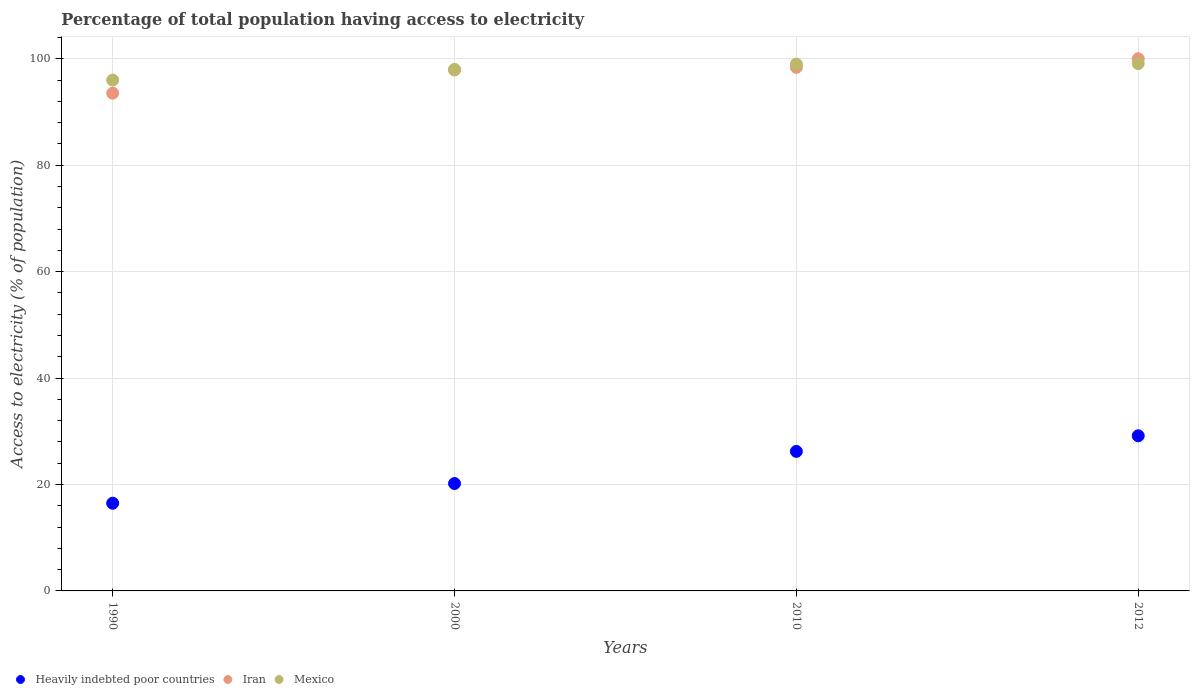Is the number of dotlines equal to the number of legend labels?
Provide a succinct answer. Yes. What is the percentage of population that have access to electricity in Iran in 2012?
Your answer should be very brief. 100. Across all years, what is the maximum percentage of population that have access to electricity in Iran?
Offer a very short reply. 100. Across all years, what is the minimum percentage of population that have access to electricity in Heavily indebted poor countries?
Offer a terse response. 16.48. What is the total percentage of population that have access to electricity in Iran in the graph?
Give a very brief answer. 389.84. What is the difference between the percentage of population that have access to electricity in Mexico in 2000 and that in 2012?
Give a very brief answer. -1.1. What is the difference between the percentage of population that have access to electricity in Mexico in 2012 and the percentage of population that have access to electricity in Heavily indebted poor countries in 2010?
Provide a succinct answer. 72.88. What is the average percentage of population that have access to electricity in Heavily indebted poor countries per year?
Your response must be concise. 23.01. In the year 2012, what is the difference between the percentage of population that have access to electricity in Heavily indebted poor countries and percentage of population that have access to electricity in Mexico?
Provide a succinct answer. -69.95. What is the ratio of the percentage of population that have access to electricity in Heavily indebted poor countries in 1990 to that in 2000?
Ensure brevity in your answer.  0.82. Is the percentage of population that have access to electricity in Iran in 2000 less than that in 2010?
Your answer should be very brief. Yes. What is the difference between the highest and the second highest percentage of population that have access to electricity in Mexico?
Your answer should be compact. 0.1. What is the difference between the highest and the lowest percentage of population that have access to electricity in Iran?
Your response must be concise. 6.46. In how many years, is the percentage of population that have access to electricity in Heavily indebted poor countries greater than the average percentage of population that have access to electricity in Heavily indebted poor countries taken over all years?
Your answer should be very brief. 2. Is the sum of the percentage of population that have access to electricity in Mexico in 1990 and 2010 greater than the maximum percentage of population that have access to electricity in Heavily indebted poor countries across all years?
Keep it short and to the point. Yes. Is the percentage of population that have access to electricity in Iran strictly less than the percentage of population that have access to electricity in Heavily indebted poor countries over the years?
Ensure brevity in your answer.  No. How many dotlines are there?
Provide a succinct answer. 3. What is the difference between two consecutive major ticks on the Y-axis?
Provide a short and direct response. 20. How many legend labels are there?
Make the answer very short. 3. What is the title of the graph?
Provide a short and direct response. Percentage of total population having access to electricity. What is the label or title of the X-axis?
Give a very brief answer. Years. What is the label or title of the Y-axis?
Make the answer very short. Access to electricity (% of population). What is the Access to electricity (% of population) of Heavily indebted poor countries in 1990?
Offer a terse response. 16.48. What is the Access to electricity (% of population) in Iran in 1990?
Provide a short and direct response. 93.54. What is the Access to electricity (% of population) of Mexico in 1990?
Your answer should be very brief. 96. What is the Access to electricity (% of population) of Heavily indebted poor countries in 2000?
Make the answer very short. 20.18. What is the Access to electricity (% of population) of Iran in 2000?
Offer a terse response. 97.9. What is the Access to electricity (% of population) of Heavily indebted poor countries in 2010?
Offer a terse response. 26.22. What is the Access to electricity (% of population) in Iran in 2010?
Ensure brevity in your answer.  98.4. What is the Access to electricity (% of population) in Mexico in 2010?
Ensure brevity in your answer.  99. What is the Access to electricity (% of population) in Heavily indebted poor countries in 2012?
Make the answer very short. 29.15. What is the Access to electricity (% of population) in Mexico in 2012?
Your answer should be very brief. 99.1. Across all years, what is the maximum Access to electricity (% of population) of Heavily indebted poor countries?
Offer a terse response. 29.15. Across all years, what is the maximum Access to electricity (% of population) in Iran?
Give a very brief answer. 100. Across all years, what is the maximum Access to electricity (% of population) in Mexico?
Provide a short and direct response. 99.1. Across all years, what is the minimum Access to electricity (% of population) of Heavily indebted poor countries?
Your answer should be very brief. 16.48. Across all years, what is the minimum Access to electricity (% of population) of Iran?
Offer a terse response. 93.54. Across all years, what is the minimum Access to electricity (% of population) in Mexico?
Make the answer very short. 96. What is the total Access to electricity (% of population) of Heavily indebted poor countries in the graph?
Provide a short and direct response. 92.04. What is the total Access to electricity (% of population) in Iran in the graph?
Your answer should be compact. 389.84. What is the total Access to electricity (% of population) in Mexico in the graph?
Keep it short and to the point. 392.1. What is the difference between the Access to electricity (% of population) of Heavily indebted poor countries in 1990 and that in 2000?
Ensure brevity in your answer.  -3.7. What is the difference between the Access to electricity (% of population) in Iran in 1990 and that in 2000?
Provide a short and direct response. -4.36. What is the difference between the Access to electricity (% of population) in Heavily indebted poor countries in 1990 and that in 2010?
Offer a terse response. -9.74. What is the difference between the Access to electricity (% of population) in Iran in 1990 and that in 2010?
Provide a short and direct response. -4.86. What is the difference between the Access to electricity (% of population) of Mexico in 1990 and that in 2010?
Ensure brevity in your answer.  -3. What is the difference between the Access to electricity (% of population) of Heavily indebted poor countries in 1990 and that in 2012?
Ensure brevity in your answer.  -12.67. What is the difference between the Access to electricity (% of population) in Iran in 1990 and that in 2012?
Keep it short and to the point. -6.46. What is the difference between the Access to electricity (% of population) of Heavily indebted poor countries in 2000 and that in 2010?
Provide a succinct answer. -6.04. What is the difference between the Access to electricity (% of population) of Iran in 2000 and that in 2010?
Offer a very short reply. -0.5. What is the difference between the Access to electricity (% of population) of Mexico in 2000 and that in 2010?
Provide a short and direct response. -1. What is the difference between the Access to electricity (% of population) of Heavily indebted poor countries in 2000 and that in 2012?
Your answer should be very brief. -8.97. What is the difference between the Access to electricity (% of population) in Heavily indebted poor countries in 2010 and that in 2012?
Give a very brief answer. -2.93. What is the difference between the Access to electricity (% of population) in Mexico in 2010 and that in 2012?
Your answer should be very brief. -0.1. What is the difference between the Access to electricity (% of population) in Heavily indebted poor countries in 1990 and the Access to electricity (% of population) in Iran in 2000?
Give a very brief answer. -81.42. What is the difference between the Access to electricity (% of population) of Heavily indebted poor countries in 1990 and the Access to electricity (% of population) of Mexico in 2000?
Your answer should be very brief. -81.52. What is the difference between the Access to electricity (% of population) of Iran in 1990 and the Access to electricity (% of population) of Mexico in 2000?
Provide a short and direct response. -4.46. What is the difference between the Access to electricity (% of population) in Heavily indebted poor countries in 1990 and the Access to electricity (% of population) in Iran in 2010?
Offer a terse response. -81.92. What is the difference between the Access to electricity (% of population) of Heavily indebted poor countries in 1990 and the Access to electricity (% of population) of Mexico in 2010?
Offer a very short reply. -82.52. What is the difference between the Access to electricity (% of population) of Iran in 1990 and the Access to electricity (% of population) of Mexico in 2010?
Ensure brevity in your answer.  -5.46. What is the difference between the Access to electricity (% of population) of Heavily indebted poor countries in 1990 and the Access to electricity (% of population) of Iran in 2012?
Your answer should be compact. -83.52. What is the difference between the Access to electricity (% of population) of Heavily indebted poor countries in 1990 and the Access to electricity (% of population) of Mexico in 2012?
Give a very brief answer. -82.62. What is the difference between the Access to electricity (% of population) in Iran in 1990 and the Access to electricity (% of population) in Mexico in 2012?
Your response must be concise. -5.56. What is the difference between the Access to electricity (% of population) of Heavily indebted poor countries in 2000 and the Access to electricity (% of population) of Iran in 2010?
Your answer should be very brief. -78.22. What is the difference between the Access to electricity (% of population) in Heavily indebted poor countries in 2000 and the Access to electricity (% of population) in Mexico in 2010?
Offer a very short reply. -78.82. What is the difference between the Access to electricity (% of population) in Iran in 2000 and the Access to electricity (% of population) in Mexico in 2010?
Ensure brevity in your answer.  -1.1. What is the difference between the Access to electricity (% of population) of Heavily indebted poor countries in 2000 and the Access to electricity (% of population) of Iran in 2012?
Your answer should be very brief. -79.82. What is the difference between the Access to electricity (% of population) of Heavily indebted poor countries in 2000 and the Access to electricity (% of population) of Mexico in 2012?
Offer a very short reply. -78.92. What is the difference between the Access to electricity (% of population) in Heavily indebted poor countries in 2010 and the Access to electricity (% of population) in Iran in 2012?
Make the answer very short. -73.78. What is the difference between the Access to electricity (% of population) in Heavily indebted poor countries in 2010 and the Access to electricity (% of population) in Mexico in 2012?
Offer a terse response. -72.88. What is the average Access to electricity (% of population) in Heavily indebted poor countries per year?
Your answer should be very brief. 23.01. What is the average Access to electricity (% of population) in Iran per year?
Offer a terse response. 97.46. What is the average Access to electricity (% of population) in Mexico per year?
Give a very brief answer. 98.03. In the year 1990, what is the difference between the Access to electricity (% of population) of Heavily indebted poor countries and Access to electricity (% of population) of Iran?
Ensure brevity in your answer.  -77.06. In the year 1990, what is the difference between the Access to electricity (% of population) of Heavily indebted poor countries and Access to electricity (% of population) of Mexico?
Your response must be concise. -79.52. In the year 1990, what is the difference between the Access to electricity (% of population) of Iran and Access to electricity (% of population) of Mexico?
Offer a terse response. -2.46. In the year 2000, what is the difference between the Access to electricity (% of population) in Heavily indebted poor countries and Access to electricity (% of population) in Iran?
Offer a very short reply. -77.72. In the year 2000, what is the difference between the Access to electricity (% of population) in Heavily indebted poor countries and Access to electricity (% of population) in Mexico?
Offer a very short reply. -77.82. In the year 2010, what is the difference between the Access to electricity (% of population) of Heavily indebted poor countries and Access to electricity (% of population) of Iran?
Make the answer very short. -72.18. In the year 2010, what is the difference between the Access to electricity (% of population) of Heavily indebted poor countries and Access to electricity (% of population) of Mexico?
Ensure brevity in your answer.  -72.78. In the year 2010, what is the difference between the Access to electricity (% of population) in Iran and Access to electricity (% of population) in Mexico?
Make the answer very short. -0.6. In the year 2012, what is the difference between the Access to electricity (% of population) of Heavily indebted poor countries and Access to electricity (% of population) of Iran?
Offer a very short reply. -70.85. In the year 2012, what is the difference between the Access to electricity (% of population) of Heavily indebted poor countries and Access to electricity (% of population) of Mexico?
Make the answer very short. -69.95. What is the ratio of the Access to electricity (% of population) of Heavily indebted poor countries in 1990 to that in 2000?
Your answer should be very brief. 0.82. What is the ratio of the Access to electricity (% of population) of Iran in 1990 to that in 2000?
Provide a succinct answer. 0.96. What is the ratio of the Access to electricity (% of population) in Mexico in 1990 to that in 2000?
Your answer should be very brief. 0.98. What is the ratio of the Access to electricity (% of population) of Heavily indebted poor countries in 1990 to that in 2010?
Your response must be concise. 0.63. What is the ratio of the Access to electricity (% of population) of Iran in 1990 to that in 2010?
Your response must be concise. 0.95. What is the ratio of the Access to electricity (% of population) in Mexico in 1990 to that in 2010?
Make the answer very short. 0.97. What is the ratio of the Access to electricity (% of population) of Heavily indebted poor countries in 1990 to that in 2012?
Offer a terse response. 0.57. What is the ratio of the Access to electricity (% of population) of Iran in 1990 to that in 2012?
Offer a terse response. 0.94. What is the ratio of the Access to electricity (% of population) in Mexico in 1990 to that in 2012?
Your response must be concise. 0.97. What is the ratio of the Access to electricity (% of population) of Heavily indebted poor countries in 2000 to that in 2010?
Make the answer very short. 0.77. What is the ratio of the Access to electricity (% of population) of Mexico in 2000 to that in 2010?
Provide a succinct answer. 0.99. What is the ratio of the Access to electricity (% of population) of Heavily indebted poor countries in 2000 to that in 2012?
Make the answer very short. 0.69. What is the ratio of the Access to electricity (% of population) in Mexico in 2000 to that in 2012?
Provide a succinct answer. 0.99. What is the ratio of the Access to electricity (% of population) of Heavily indebted poor countries in 2010 to that in 2012?
Provide a short and direct response. 0.9. What is the difference between the highest and the second highest Access to electricity (% of population) of Heavily indebted poor countries?
Your response must be concise. 2.93. What is the difference between the highest and the second highest Access to electricity (% of population) in Mexico?
Make the answer very short. 0.1. What is the difference between the highest and the lowest Access to electricity (% of population) of Heavily indebted poor countries?
Make the answer very short. 12.67. What is the difference between the highest and the lowest Access to electricity (% of population) in Iran?
Offer a terse response. 6.46. 